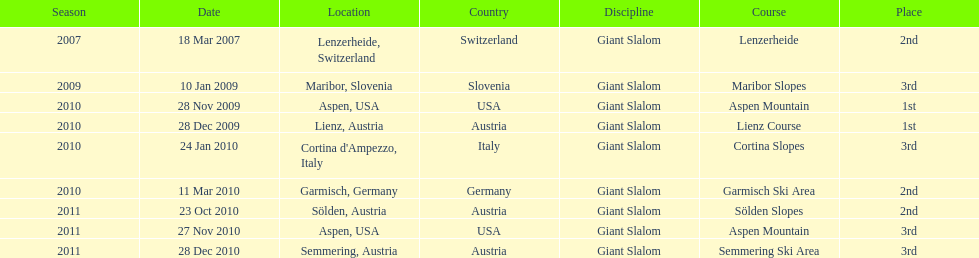How many races were in 2010? 5. 